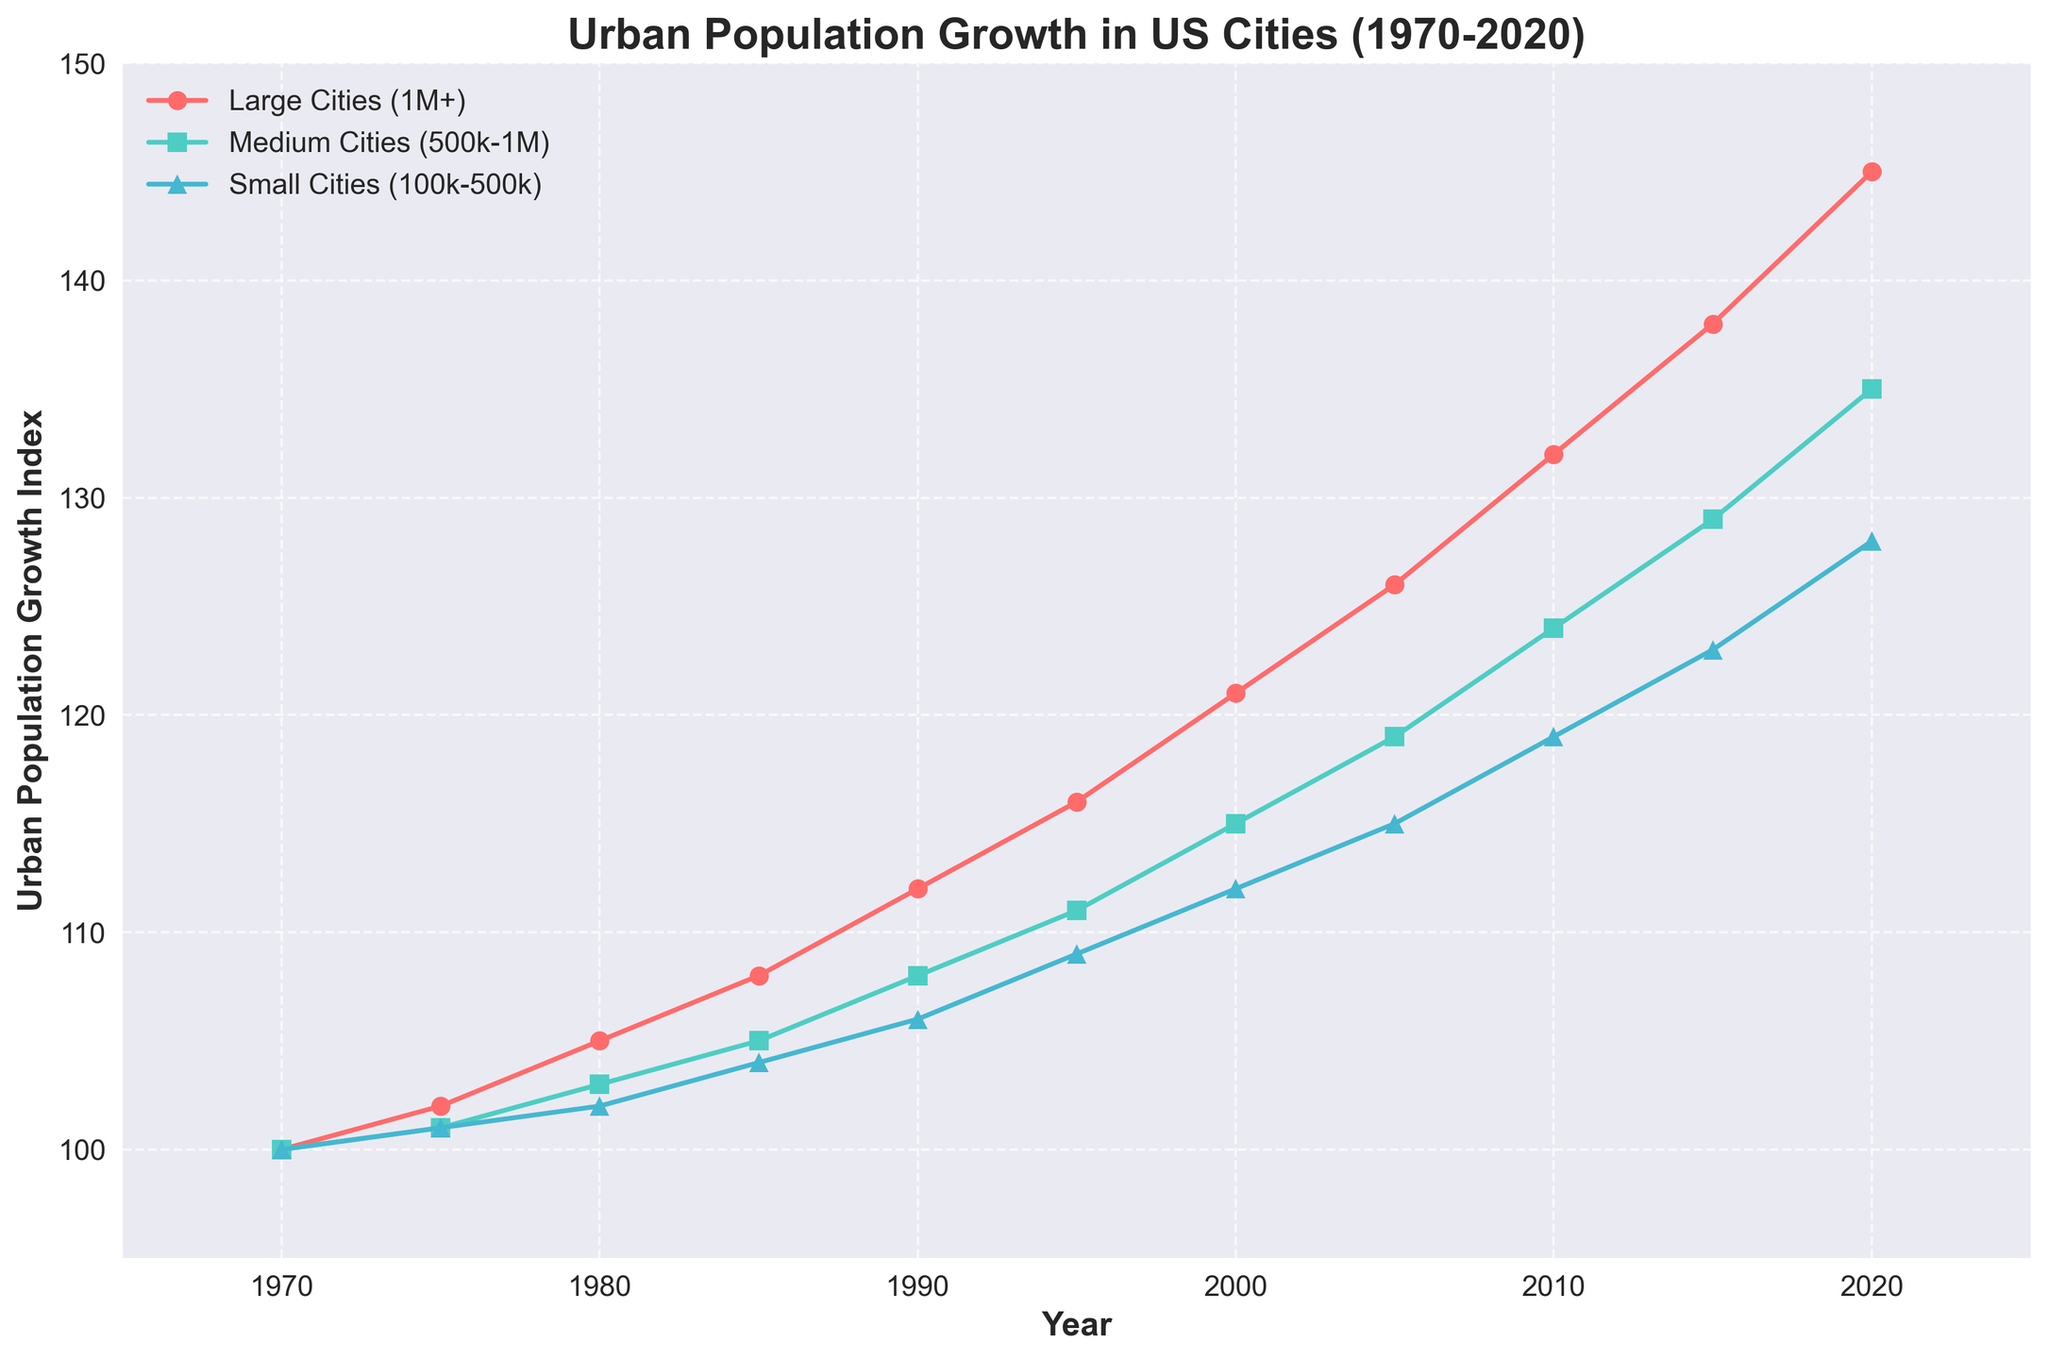What's the urban population growth index of large cities in 1990? On the chart, locate the curve for 'Large Cities (1M+)' and find the corresponding value at the year 1990. The index is shown next to the marker.
Answer: 112 In which year did medium cities experience the same growth index as small cities had in 2005? The growth index for small cities in 2005 is 115. Now check the 'Medium Cities (500k-1M)' curve and identify the year that matches this value.
Answer: 2020 Which city size experienced the highest growth index in 2020, and what was the index? Compare the endpoints of all three curves at the year 2020. Look for the highest point and its corresponding growth index.
Answer: Large Cities (1M+), 145 How much did the urban population growth index for small cities increase from 1980 to 2020? Identify the values for 'Small Cities (100k-500k)' in 1980 and 2020, then calculate the difference: \(128 - 102 = 26\).
Answer: 26 Between 2000 and 2010, did medium cities or small cities have a higher growth index? Compare the growth index values of 'Medium Cities (500k-1M)' and 'Small Cities (100k-500k)' in 2000 and 2010 respectively. Medium cities have a higher index (124 vs. 119).
Answer: Medium Cities (500k-1M) What's the average growth index of large cities at the start and end years (1970 and 2020)? Find the growth index of 'Large Cities (1M+)' in 1970 and 2020, then compute the average: \((100 + 145) / 2 = 122.5\).
Answer: 122.5 Which year marks the first occurrence of small cities surpassing an index of 120? Trace the 'Small Cities (100k-500k)' curve and identify the year when it first exceeds the value of 120.
Answer: 2020 Compare the slope of the growth curves for large and medium cities between 1995 and 2005. Which has a steeper increase? Determine the increase from 1995 to 2005 for both large (\(126 - 116 = 10\)) and medium (\(119 - 111 = 8\)) cities. The larger increase indicates a steeper slope.
Answer: Large Cities (1M+) What is the color used to represent medium cities in the plot? Identify the distinct color associated with the 'Medium Cities (500k-1M)' data points on the plot.
Answer: Green Which city size had the least consistent growth over the 50-year span? Evaluate the smoothness and fluctuations in the trajectories of all three curves over the time range.
Answer: Small Cities (100k-500k) 